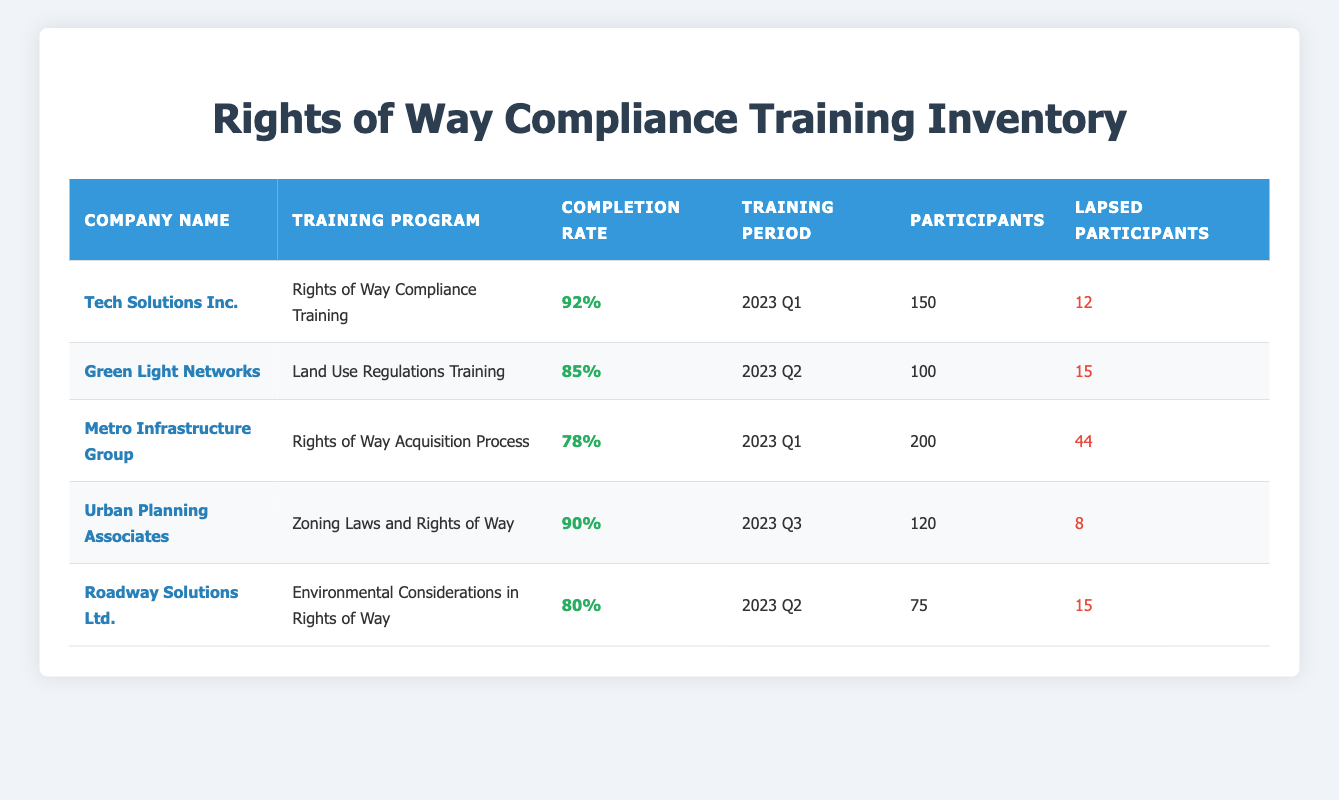What is the highest completion rate for the training programs listed? The highest completion rate can be found by reviewing the "Completion Rate" column. Tech Solutions Inc. has a completion rate of 92%, which is higher than all other companies listed.
Answer: 92% Which company had the most participants in their training program? By checking the "Participants" column, Metro Infrastructure Group has the highest number of participants, totaling 200.
Answer: 200 How many lapsed participants were there in total across all training programs? To find the total lapsed participants, we add the lapsed participants from all entries: 12 + 15 + 44 + 8 + 15 = 94.
Answer: 94 Was the completion rate for Roadway Solutions Ltd. greater than or equal to 80%? The completion rate for Roadway Solutions Ltd. is 80%, which is equal to 80%. This matches the criteria of being greater than or equal.
Answer: Yes What is the average completion rate of the training programs listed? To calculate the average, convert the completion rates into percentages: (92 + 85 + 78 + 90 + 80) = 425. Divide by the number of entries (5): 425 / 5 = 85.
Answer: 85% Which training program had the lowest completion rate? Looking at the "Completion Rate" column, Metro Infrastructure Group's Rights of Way Acquisition Process has the lowest completion rate at 78%.
Answer: 78% Did Urban Planning Associates have a higher completion rate than Green Light Networks? Urban Planning Associates had a completion rate of 90%, while Green Light Networks had 85%. Since 90% is greater than 85%, the answer is yes.
Answer: Yes What is the difference in the number of lapsed participants between Tech Solutions Inc. and Urban Planning Associates? Tech Solutions Inc. has 12 lapsed participants and Urban Planning Associates has 8 lapsed participants. The difference is 12 - 8 = 4.
Answer: 4 Is there any company that had a training program with a completion rate below 80%? Metro Infrastructure Group's Rights of Way Acquisition Process had a completion rate of 78%, which is below 80%. Therefore, the answer is yes.
Answer: Yes 